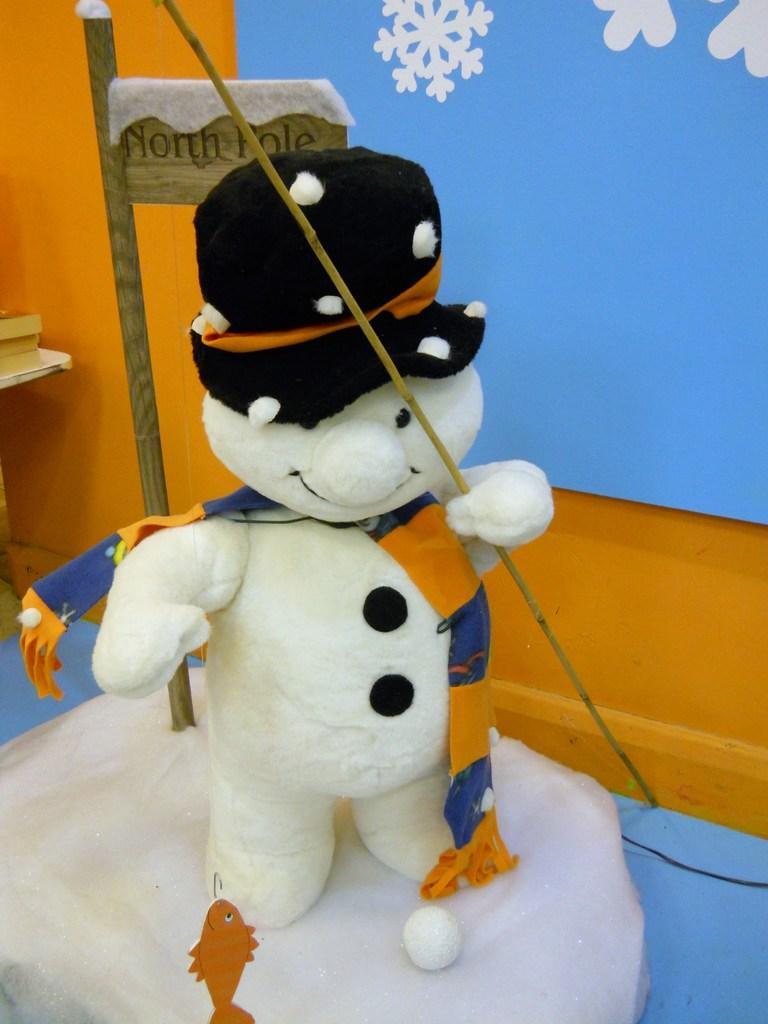In one or two sentences, can you explain what this image depicts? In the center of this picture we can see a white color object seems to be a soft toy holding a stick, wearing black color cap and standing. In the background we can see some pictures on a blue color object and we can see the text on a board attached to the pole and we can see some other objects and the fish. 